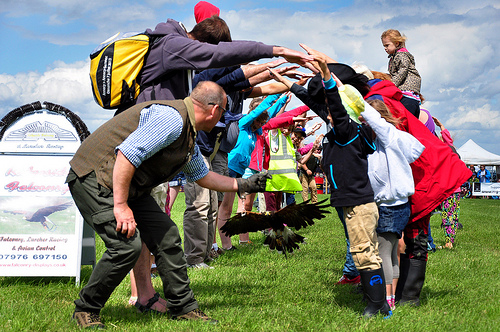<image>
Can you confirm if the kid is above the bird? Yes. The kid is positioned above the bird in the vertical space, higher up in the scene. 